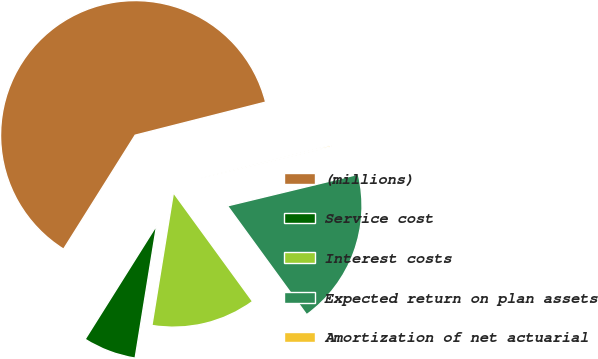Convert chart to OTSL. <chart><loc_0><loc_0><loc_500><loc_500><pie_chart><fcel>(millions)<fcel>Service cost<fcel>Interest costs<fcel>Expected return on plan assets<fcel>Amortization of net actuarial<nl><fcel>62.12%<fcel>6.37%<fcel>12.57%<fcel>18.76%<fcel>0.18%<nl></chart> 